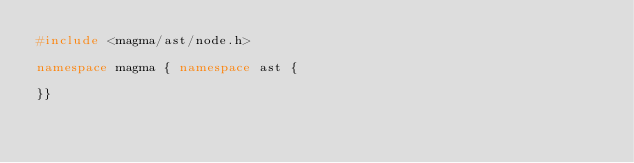Convert code to text. <code><loc_0><loc_0><loc_500><loc_500><_C++_>#include <magma/ast/node.h>

namespace magma { namespace ast {

}}


</code> 